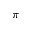<formula> <loc_0><loc_0><loc_500><loc_500>\pi</formula> 